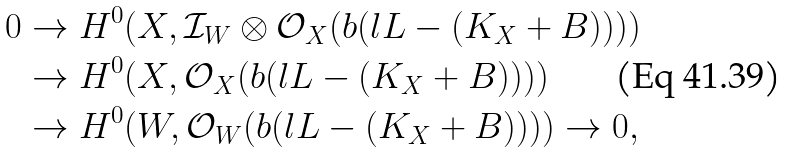<formula> <loc_0><loc_0><loc_500><loc_500>0 & \to H ^ { 0 } ( X , \mathcal { I } _ { W } \otimes \mathcal { O } _ { X } ( b ( l L - ( K _ { X } + B ) ) ) ) \\ & \to H ^ { 0 } ( X , \mathcal { O } _ { X } ( b ( l L - ( K _ { X } + B ) ) ) ) \\ & \to H ^ { 0 } ( W , \mathcal { O } _ { W } ( b ( l L - ( K _ { X } + B ) ) ) ) \to 0 ,</formula> 